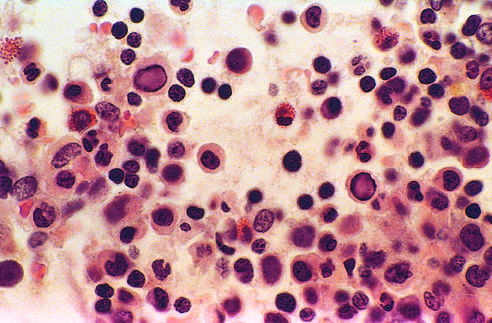what is infected with parvovirus b19?
Answer the question using a single word or phrase. Bone marrow from an infant 